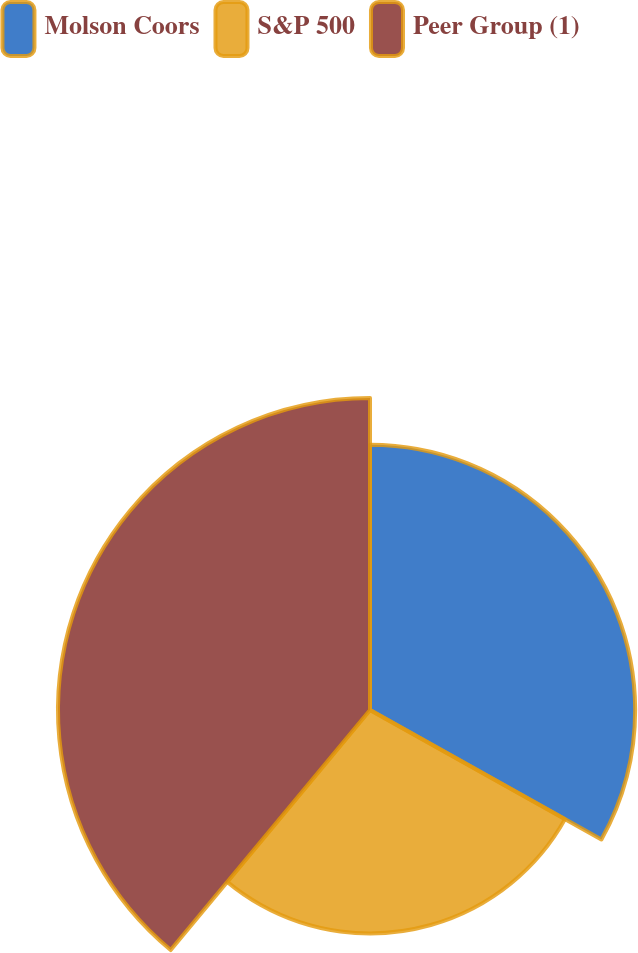Convert chart. <chart><loc_0><loc_0><loc_500><loc_500><pie_chart><fcel>Molson Coors<fcel>S&P 500<fcel>Peer Group (1)<nl><fcel>33.12%<fcel>27.91%<fcel>38.97%<nl></chart> 